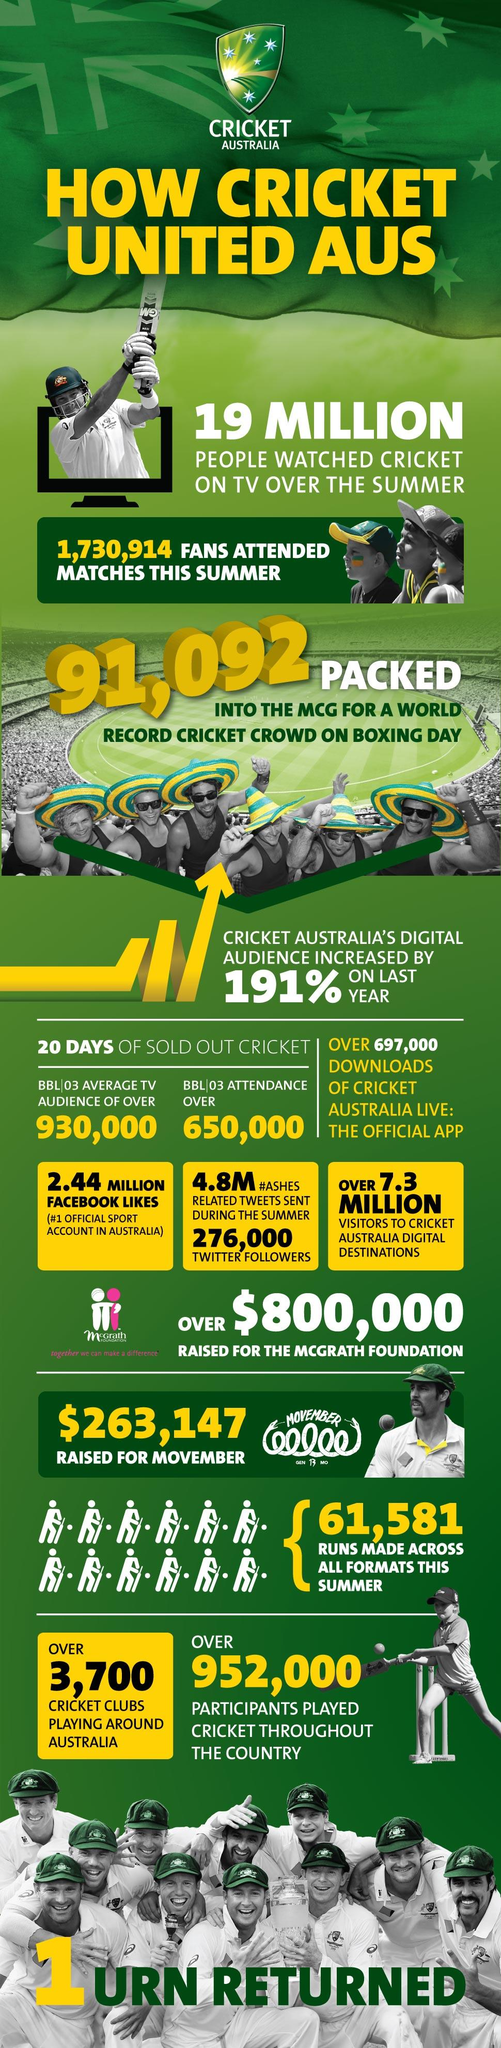Mention a couple of crucial points in this snapshot. During the harvest, 1,730,914 people witnessed the Australia match. There are over 3,700 cricket associations in Australia. According to the official Cricket application of Australia, 697,000 people have installed it. As of today, the support for Cricket Australia on Facebook is 2.44 million. 